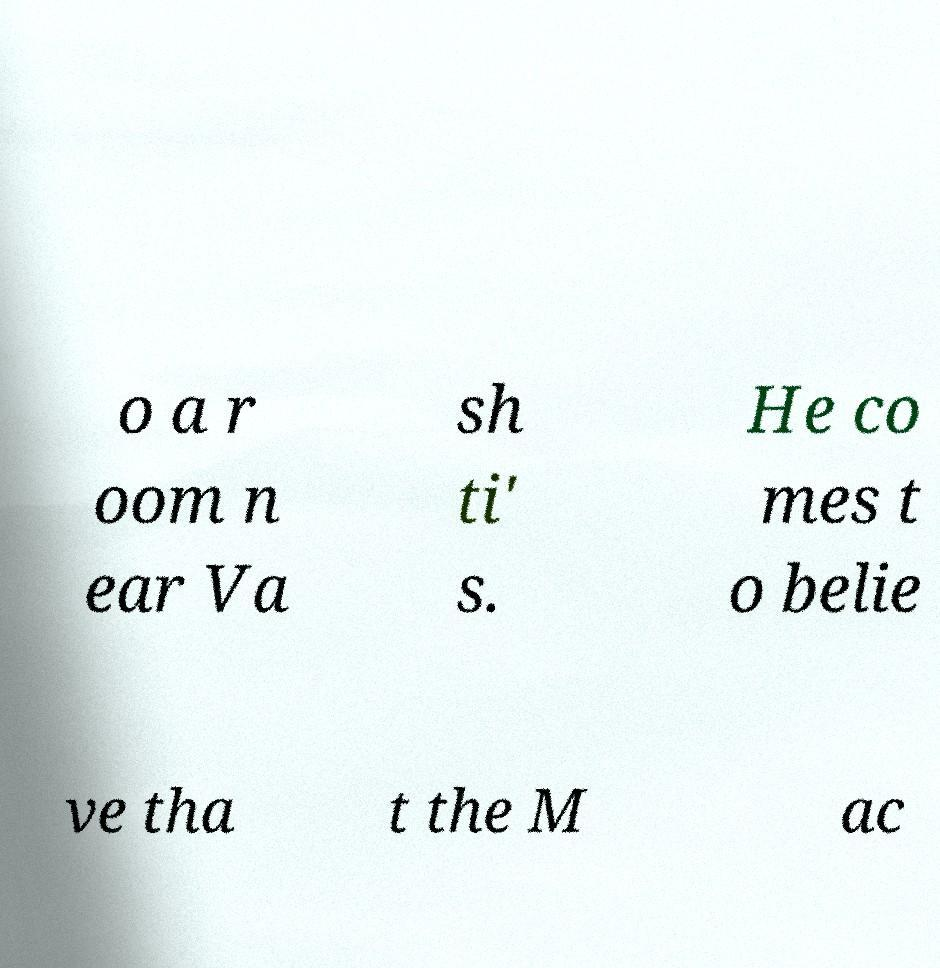Please read and relay the text visible in this image. What does it say? o a r oom n ear Va sh ti' s. He co mes t o belie ve tha t the M ac 